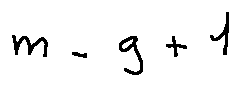<formula> <loc_0><loc_0><loc_500><loc_500>m - g + 1</formula> 